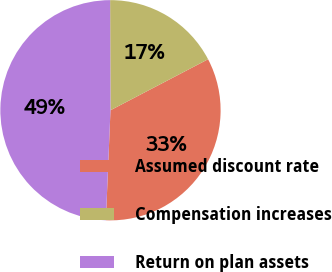<chart> <loc_0><loc_0><loc_500><loc_500><pie_chart><fcel>Assumed discount rate<fcel>Compensation increases<fcel>Return on plan assets<nl><fcel>33.33%<fcel>17.39%<fcel>49.28%<nl></chart> 